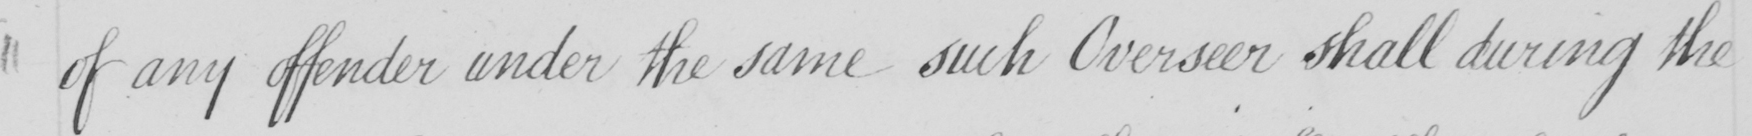What is written in this line of handwriting? of any offender under the same such Overseer shall during the 